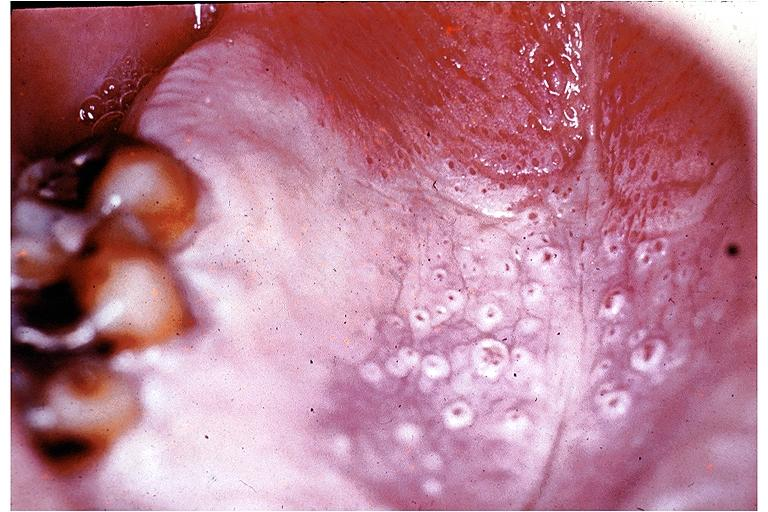does this image show nicotine stomatitis?
Answer the question using a single word or phrase. Yes 